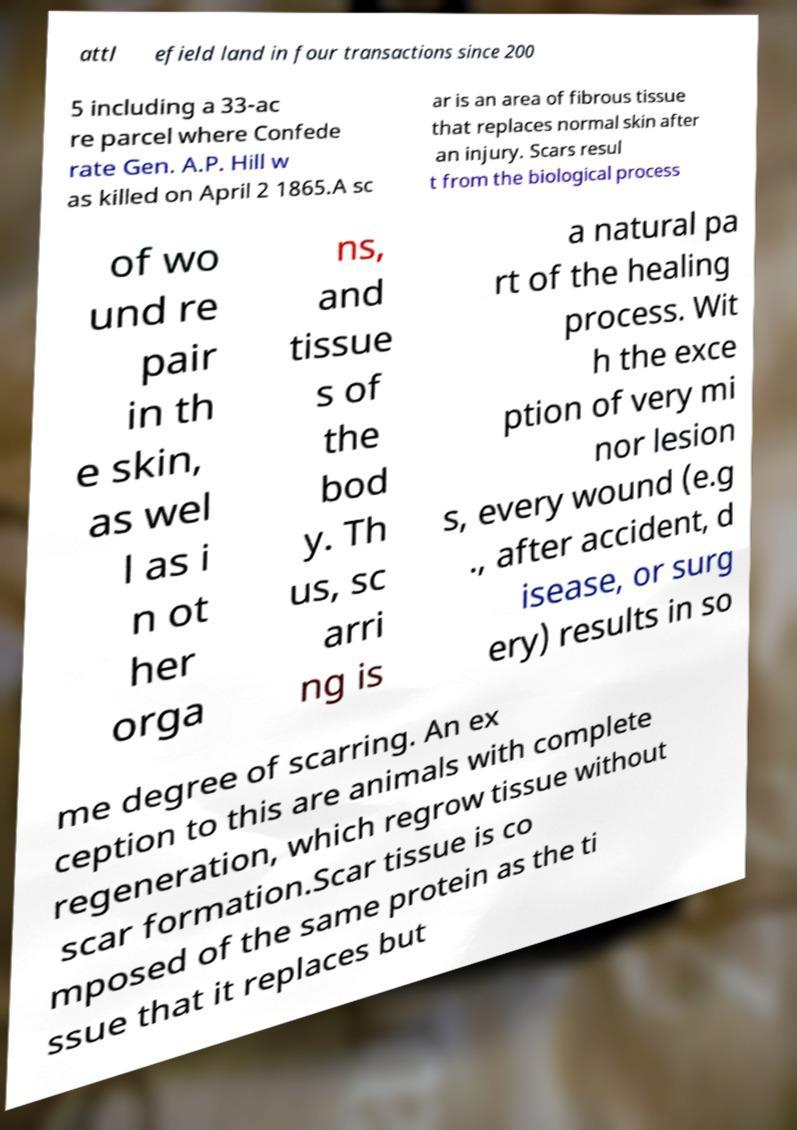For documentation purposes, I need the text within this image transcribed. Could you provide that? attl efield land in four transactions since 200 5 including a 33-ac re parcel where Confede rate Gen. A.P. Hill w as killed on April 2 1865.A sc ar is an area of fibrous tissue that replaces normal skin after an injury. Scars resul t from the biological process of wo und re pair in th e skin, as wel l as i n ot her orga ns, and tissue s of the bod y. Th us, sc arri ng is a natural pa rt of the healing process. Wit h the exce ption of very mi nor lesion s, every wound (e.g ., after accident, d isease, or surg ery) results in so me degree of scarring. An ex ception to this are animals with complete regeneration, which regrow tissue without scar formation.Scar tissue is co mposed of the same protein as the ti ssue that it replaces but 